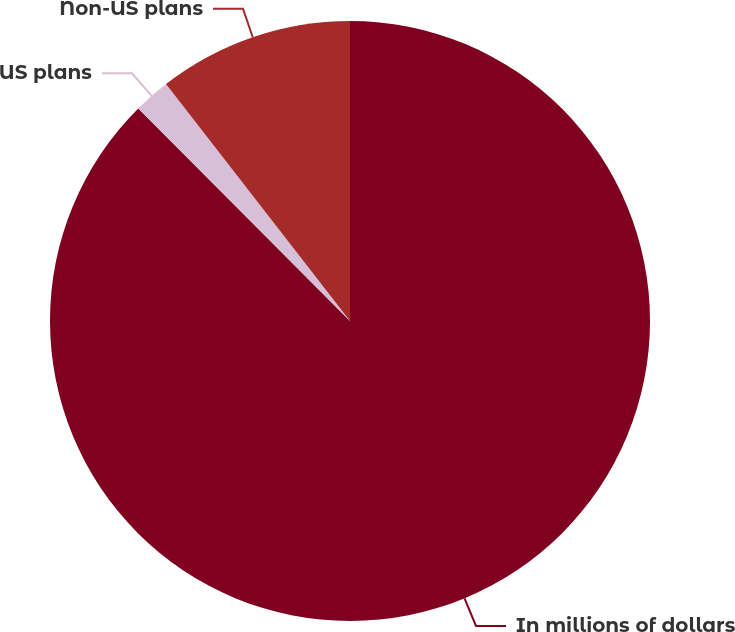<chart> <loc_0><loc_0><loc_500><loc_500><pie_chart><fcel>In millions of dollars<fcel>US plans<fcel>Non-US plans<nl><fcel>87.53%<fcel>1.96%<fcel>10.51%<nl></chart> 